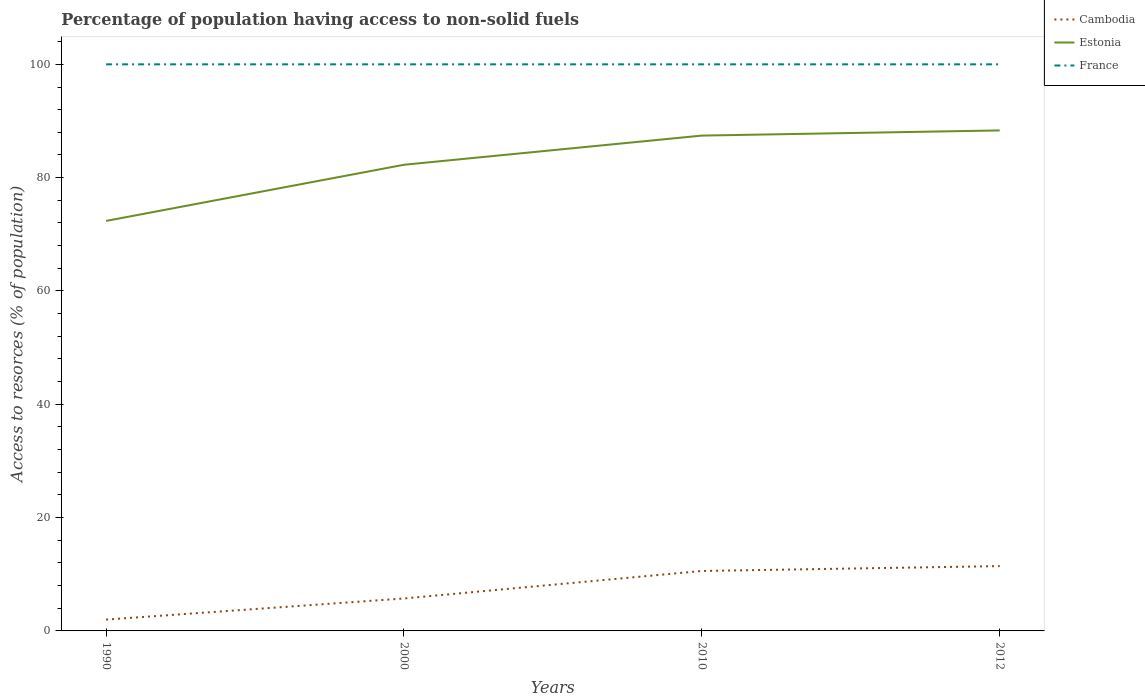Is the number of lines equal to the number of legend labels?
Your answer should be compact. Yes. Across all years, what is the maximum percentage of population having access to non-solid fuels in Cambodia?
Your answer should be compact. 2. What is the total percentage of population having access to non-solid fuels in Estonia in the graph?
Your answer should be compact. -15.97. What is the difference between the highest and the second highest percentage of population having access to non-solid fuels in Estonia?
Your answer should be very brief. 15.97. What is the difference between the highest and the lowest percentage of population having access to non-solid fuels in France?
Offer a very short reply. 0. Is the percentage of population having access to non-solid fuels in France strictly greater than the percentage of population having access to non-solid fuels in Cambodia over the years?
Offer a terse response. No. What is the difference between two consecutive major ticks on the Y-axis?
Your response must be concise. 20. Are the values on the major ticks of Y-axis written in scientific E-notation?
Give a very brief answer. No. Does the graph contain any zero values?
Provide a short and direct response. No. How are the legend labels stacked?
Ensure brevity in your answer.  Vertical. What is the title of the graph?
Offer a very short reply. Percentage of population having access to non-solid fuels. Does "Uruguay" appear as one of the legend labels in the graph?
Make the answer very short. No. What is the label or title of the X-axis?
Give a very brief answer. Years. What is the label or title of the Y-axis?
Your response must be concise. Access to resorces (% of population). What is the Access to resorces (% of population) in Cambodia in 1990?
Keep it short and to the point. 2. What is the Access to resorces (% of population) in Estonia in 1990?
Offer a very short reply. 72.36. What is the Access to resorces (% of population) of Cambodia in 2000?
Offer a very short reply. 5.73. What is the Access to resorces (% of population) of Estonia in 2000?
Keep it short and to the point. 82.28. What is the Access to resorces (% of population) of Cambodia in 2010?
Make the answer very short. 10.58. What is the Access to resorces (% of population) of Estonia in 2010?
Your answer should be compact. 87.42. What is the Access to resorces (% of population) in France in 2010?
Provide a short and direct response. 100. What is the Access to resorces (% of population) in Cambodia in 2012?
Give a very brief answer. 11.44. What is the Access to resorces (% of population) of Estonia in 2012?
Offer a terse response. 88.34. Across all years, what is the maximum Access to resorces (% of population) of Cambodia?
Offer a very short reply. 11.44. Across all years, what is the maximum Access to resorces (% of population) in Estonia?
Your response must be concise. 88.34. Across all years, what is the minimum Access to resorces (% of population) of Cambodia?
Keep it short and to the point. 2. Across all years, what is the minimum Access to resorces (% of population) of Estonia?
Your response must be concise. 72.36. Across all years, what is the minimum Access to resorces (% of population) of France?
Offer a very short reply. 100. What is the total Access to resorces (% of population) of Cambodia in the graph?
Keep it short and to the point. 29.75. What is the total Access to resorces (% of population) in Estonia in the graph?
Your answer should be very brief. 330.4. What is the difference between the Access to resorces (% of population) in Cambodia in 1990 and that in 2000?
Keep it short and to the point. -3.73. What is the difference between the Access to resorces (% of population) in Estonia in 1990 and that in 2000?
Your response must be concise. -9.91. What is the difference between the Access to resorces (% of population) in Cambodia in 1990 and that in 2010?
Offer a very short reply. -8.58. What is the difference between the Access to resorces (% of population) in Estonia in 1990 and that in 2010?
Offer a very short reply. -15.06. What is the difference between the Access to resorces (% of population) in Cambodia in 1990 and that in 2012?
Keep it short and to the point. -9.44. What is the difference between the Access to resorces (% of population) in Estonia in 1990 and that in 2012?
Provide a short and direct response. -15.97. What is the difference between the Access to resorces (% of population) in France in 1990 and that in 2012?
Make the answer very short. 0. What is the difference between the Access to resorces (% of population) of Cambodia in 2000 and that in 2010?
Keep it short and to the point. -4.85. What is the difference between the Access to resorces (% of population) in Estonia in 2000 and that in 2010?
Provide a succinct answer. -5.15. What is the difference between the Access to resorces (% of population) of Cambodia in 2000 and that in 2012?
Your answer should be very brief. -5.71. What is the difference between the Access to resorces (% of population) in Estonia in 2000 and that in 2012?
Your answer should be compact. -6.06. What is the difference between the Access to resorces (% of population) in France in 2000 and that in 2012?
Make the answer very short. 0. What is the difference between the Access to resorces (% of population) of Cambodia in 2010 and that in 2012?
Your answer should be very brief. -0.86. What is the difference between the Access to resorces (% of population) of Estonia in 2010 and that in 2012?
Your answer should be very brief. -0.91. What is the difference between the Access to resorces (% of population) of Cambodia in 1990 and the Access to resorces (% of population) of Estonia in 2000?
Your answer should be very brief. -80.28. What is the difference between the Access to resorces (% of population) of Cambodia in 1990 and the Access to resorces (% of population) of France in 2000?
Ensure brevity in your answer.  -98. What is the difference between the Access to resorces (% of population) of Estonia in 1990 and the Access to resorces (% of population) of France in 2000?
Provide a short and direct response. -27.64. What is the difference between the Access to resorces (% of population) in Cambodia in 1990 and the Access to resorces (% of population) in Estonia in 2010?
Provide a short and direct response. -85.42. What is the difference between the Access to resorces (% of population) in Cambodia in 1990 and the Access to resorces (% of population) in France in 2010?
Provide a short and direct response. -98. What is the difference between the Access to resorces (% of population) of Estonia in 1990 and the Access to resorces (% of population) of France in 2010?
Your answer should be very brief. -27.64. What is the difference between the Access to resorces (% of population) of Cambodia in 1990 and the Access to resorces (% of population) of Estonia in 2012?
Provide a short and direct response. -86.34. What is the difference between the Access to resorces (% of population) of Cambodia in 1990 and the Access to resorces (% of population) of France in 2012?
Provide a short and direct response. -98. What is the difference between the Access to resorces (% of population) of Estonia in 1990 and the Access to resorces (% of population) of France in 2012?
Your response must be concise. -27.64. What is the difference between the Access to resorces (% of population) in Cambodia in 2000 and the Access to resorces (% of population) in Estonia in 2010?
Ensure brevity in your answer.  -81.7. What is the difference between the Access to resorces (% of population) in Cambodia in 2000 and the Access to resorces (% of population) in France in 2010?
Provide a short and direct response. -94.27. What is the difference between the Access to resorces (% of population) in Estonia in 2000 and the Access to resorces (% of population) in France in 2010?
Give a very brief answer. -17.72. What is the difference between the Access to resorces (% of population) of Cambodia in 2000 and the Access to resorces (% of population) of Estonia in 2012?
Ensure brevity in your answer.  -82.61. What is the difference between the Access to resorces (% of population) in Cambodia in 2000 and the Access to resorces (% of population) in France in 2012?
Make the answer very short. -94.27. What is the difference between the Access to resorces (% of population) in Estonia in 2000 and the Access to resorces (% of population) in France in 2012?
Your answer should be very brief. -17.72. What is the difference between the Access to resorces (% of population) in Cambodia in 2010 and the Access to resorces (% of population) in Estonia in 2012?
Provide a succinct answer. -77.75. What is the difference between the Access to resorces (% of population) in Cambodia in 2010 and the Access to resorces (% of population) in France in 2012?
Your response must be concise. -89.42. What is the difference between the Access to resorces (% of population) of Estonia in 2010 and the Access to resorces (% of population) of France in 2012?
Your answer should be compact. -12.58. What is the average Access to resorces (% of population) in Cambodia per year?
Provide a succinct answer. 7.44. What is the average Access to resorces (% of population) of Estonia per year?
Your answer should be compact. 82.6. In the year 1990, what is the difference between the Access to resorces (% of population) in Cambodia and Access to resorces (% of population) in Estonia?
Give a very brief answer. -70.36. In the year 1990, what is the difference between the Access to resorces (% of population) in Cambodia and Access to resorces (% of population) in France?
Give a very brief answer. -98. In the year 1990, what is the difference between the Access to resorces (% of population) of Estonia and Access to resorces (% of population) of France?
Your answer should be very brief. -27.64. In the year 2000, what is the difference between the Access to resorces (% of population) of Cambodia and Access to resorces (% of population) of Estonia?
Provide a succinct answer. -76.55. In the year 2000, what is the difference between the Access to resorces (% of population) in Cambodia and Access to resorces (% of population) in France?
Provide a short and direct response. -94.27. In the year 2000, what is the difference between the Access to resorces (% of population) of Estonia and Access to resorces (% of population) of France?
Make the answer very short. -17.72. In the year 2010, what is the difference between the Access to resorces (% of population) in Cambodia and Access to resorces (% of population) in Estonia?
Offer a terse response. -76.84. In the year 2010, what is the difference between the Access to resorces (% of population) of Cambodia and Access to resorces (% of population) of France?
Your answer should be very brief. -89.42. In the year 2010, what is the difference between the Access to resorces (% of population) in Estonia and Access to resorces (% of population) in France?
Ensure brevity in your answer.  -12.58. In the year 2012, what is the difference between the Access to resorces (% of population) of Cambodia and Access to resorces (% of population) of Estonia?
Ensure brevity in your answer.  -76.9. In the year 2012, what is the difference between the Access to resorces (% of population) of Cambodia and Access to resorces (% of population) of France?
Keep it short and to the point. -88.56. In the year 2012, what is the difference between the Access to resorces (% of population) of Estonia and Access to resorces (% of population) of France?
Keep it short and to the point. -11.66. What is the ratio of the Access to resorces (% of population) in Cambodia in 1990 to that in 2000?
Keep it short and to the point. 0.35. What is the ratio of the Access to resorces (% of population) of Estonia in 1990 to that in 2000?
Keep it short and to the point. 0.88. What is the ratio of the Access to resorces (% of population) in Cambodia in 1990 to that in 2010?
Your answer should be compact. 0.19. What is the ratio of the Access to resorces (% of population) in Estonia in 1990 to that in 2010?
Make the answer very short. 0.83. What is the ratio of the Access to resorces (% of population) in Cambodia in 1990 to that in 2012?
Offer a very short reply. 0.17. What is the ratio of the Access to resorces (% of population) of Estonia in 1990 to that in 2012?
Offer a very short reply. 0.82. What is the ratio of the Access to resorces (% of population) in Cambodia in 2000 to that in 2010?
Your response must be concise. 0.54. What is the ratio of the Access to resorces (% of population) of Estonia in 2000 to that in 2010?
Ensure brevity in your answer.  0.94. What is the ratio of the Access to resorces (% of population) in France in 2000 to that in 2010?
Give a very brief answer. 1. What is the ratio of the Access to resorces (% of population) of Cambodia in 2000 to that in 2012?
Keep it short and to the point. 0.5. What is the ratio of the Access to resorces (% of population) of Estonia in 2000 to that in 2012?
Provide a short and direct response. 0.93. What is the ratio of the Access to resorces (% of population) in Cambodia in 2010 to that in 2012?
Offer a terse response. 0.93. What is the ratio of the Access to resorces (% of population) of Estonia in 2010 to that in 2012?
Make the answer very short. 0.99. What is the difference between the highest and the second highest Access to resorces (% of population) in Cambodia?
Offer a very short reply. 0.86. What is the difference between the highest and the second highest Access to resorces (% of population) in Estonia?
Provide a succinct answer. 0.91. What is the difference between the highest and the lowest Access to resorces (% of population) of Cambodia?
Make the answer very short. 9.44. What is the difference between the highest and the lowest Access to resorces (% of population) in Estonia?
Make the answer very short. 15.97. What is the difference between the highest and the lowest Access to resorces (% of population) of France?
Ensure brevity in your answer.  0. 